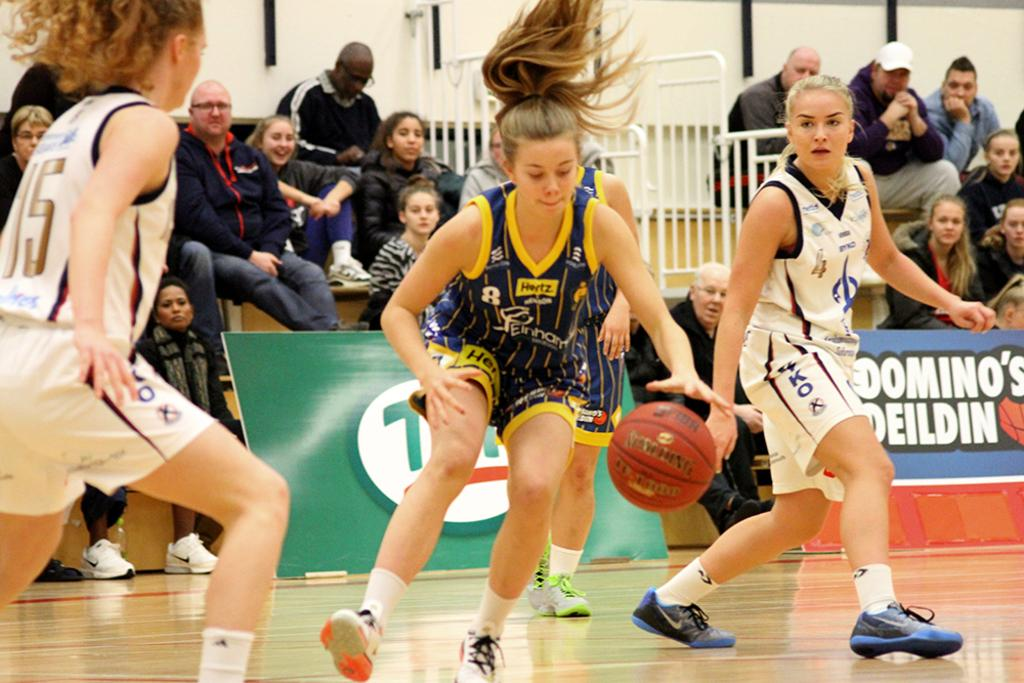<image>
Summarize the visual content of the image. A woman with a Hertz logo at the neck of her blue shirt bounces the ball. 